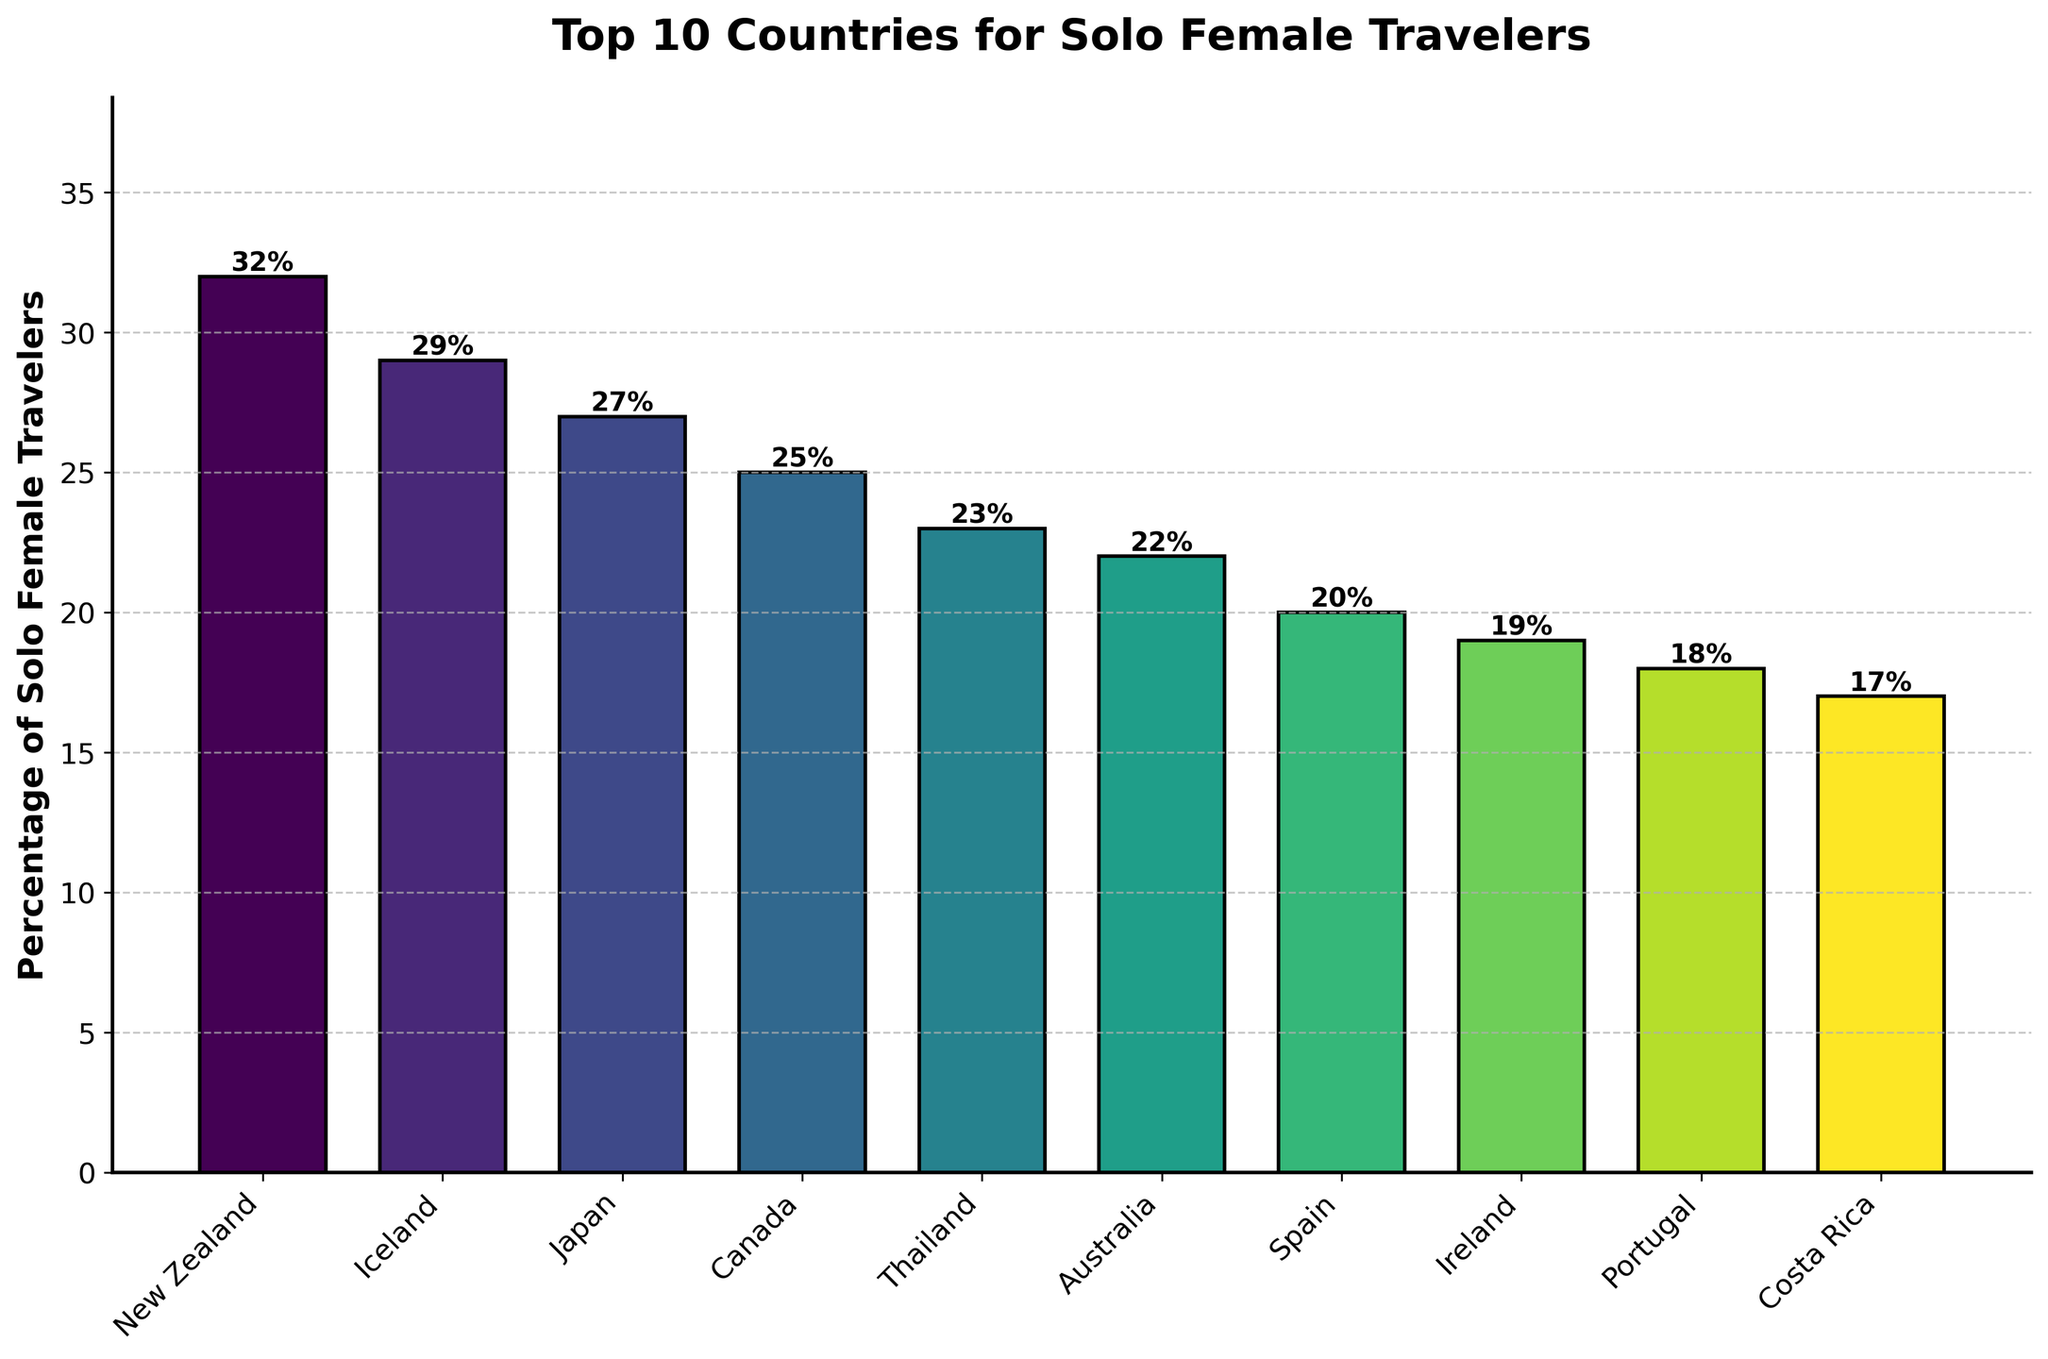Which country has the highest percentage of solo female travelers? From the figure, the tallest bar represents New Zealand with a percentage of 32, making it the highest percentage.
Answer: New Zealand How many countries have a percentage of solo female travelers above 25%? By examining the bars, New Zealand, Iceland, and Japan have percentages above 25%, totaling three countries.
Answer: 3 What is the total percentage of solo female travelers in the top 3 countries? Summing the percentages of New Zealand (32%), Iceland (29%), and Japan (27%): 32 + 29 + 27 = 88%.
Answer: 88% Which country has a higher percentage of solo female travelers, Canada or Thailand? By comparing the bars, Canada has 25% while Thailand has 23%, so Canada has a higher percentage.
Answer: Canada Is the percentage of solo female travelers in Costa Rica more than half of that in New Zealand? Costa Rica has 17% and New Zealand has 32%. More than half would be 32 / 2 = 16%. Since 17% > 16%, yes, Costa Rica's percentage is more than half.
Answer: Yes What is the average percentage of solo female travelers for the countries listed? Sum the percentages for all 10 countries: 32 + 29 + 27 + 25 + 23 + 22 + 20 + 19 + 18 + 17 = 232. Then divide by 10: 232 / 10 = 23.2%.
Answer: 23.2% Which country has the closest percentage to 20%? From the figure, Spain has a percentage of exactly 20%, making it the closest.
Answer: Spain Compare Australia and Portugal. Which of them has a higher percentage of solo female travelers and by how much? Australia has 22% and Portugal has 18%. The difference is 22 - 18 = 4%. Therefore, Australia has a higher percentage by 4%.
Answer: Australia, 4% Between Iceland and Ireland, which country has a lower percentage of solo female travelers? By examining the bars, Iceland has 29% while Ireland has 19%. Thus, Ireland has a lower percentage.
Answer: Ireland What is the difference between the highest and lowest percentages of solo female travelers in the listed countries? The highest percentage is for New Zealand (32%) and the lowest is for Costa Rica (17%). The difference is 32 - 17 = 15%.
Answer: 15% 